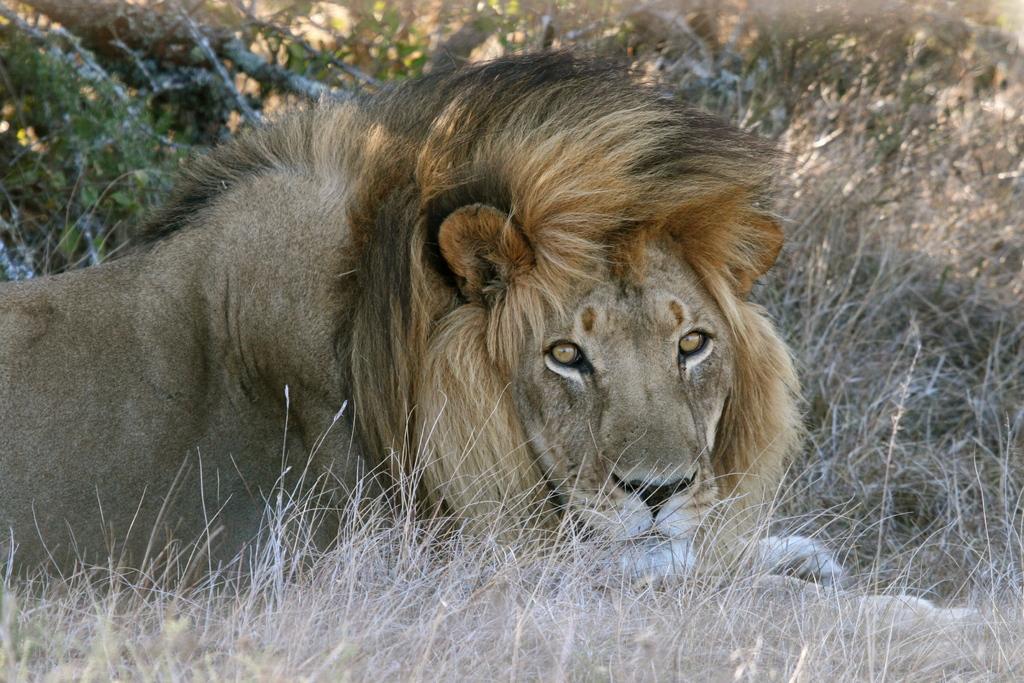Can you describe this image briefly? In this picture we can see a lion, at the bottom there is grass, in the background we can see some plants. 